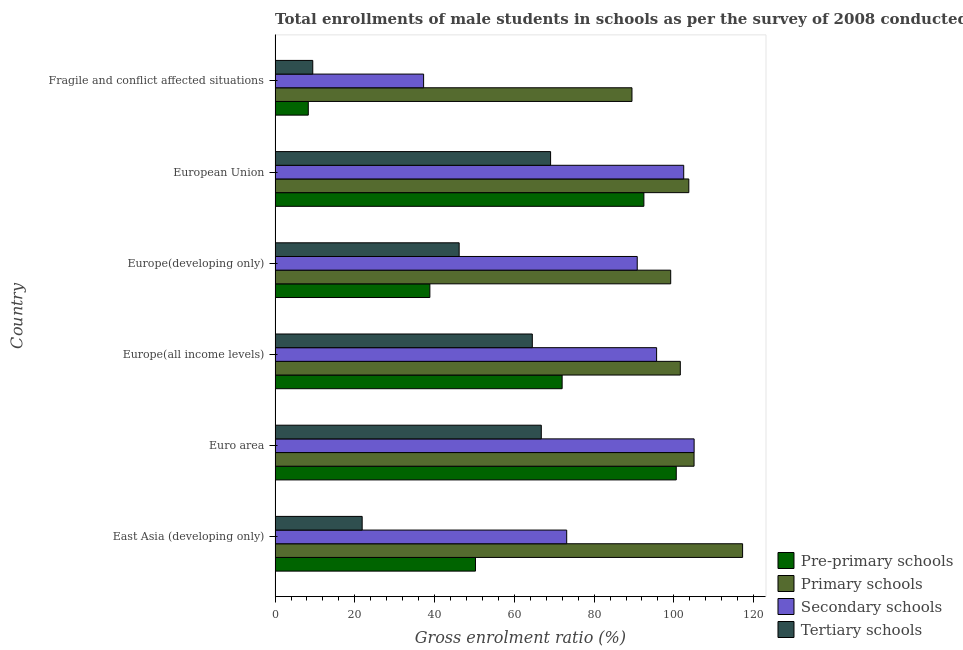How many groups of bars are there?
Make the answer very short. 6. Are the number of bars on each tick of the Y-axis equal?
Offer a very short reply. Yes. How many bars are there on the 1st tick from the top?
Offer a terse response. 4. How many bars are there on the 1st tick from the bottom?
Your answer should be very brief. 4. In how many cases, is the number of bars for a given country not equal to the number of legend labels?
Give a very brief answer. 0. What is the gross enrolment ratio(male) in primary schools in Europe(all income levels)?
Your response must be concise. 101.62. Across all countries, what is the maximum gross enrolment ratio(male) in primary schools?
Your response must be concise. 117.24. Across all countries, what is the minimum gross enrolment ratio(male) in pre-primary schools?
Provide a short and direct response. 8.33. In which country was the gross enrolment ratio(male) in pre-primary schools minimum?
Provide a succinct answer. Fragile and conflict affected situations. What is the total gross enrolment ratio(male) in primary schools in the graph?
Offer a very short reply. 616.4. What is the difference between the gross enrolment ratio(male) in tertiary schools in Euro area and that in Fragile and conflict affected situations?
Provide a succinct answer. 57.31. What is the difference between the gross enrolment ratio(male) in tertiary schools in Europe(developing only) and the gross enrolment ratio(male) in primary schools in Europe(all income levels)?
Your answer should be compact. -55.46. What is the average gross enrolment ratio(male) in primary schools per country?
Your response must be concise. 102.73. What is the difference between the gross enrolment ratio(male) in tertiary schools and gross enrolment ratio(male) in secondary schools in Europe(developing only)?
Your answer should be very brief. -44.66. What is the ratio of the gross enrolment ratio(male) in secondary schools in East Asia (developing only) to that in Europe(all income levels)?
Provide a short and direct response. 0.76. Is the difference between the gross enrolment ratio(male) in tertiary schools in Euro area and European Union greater than the difference between the gross enrolment ratio(male) in primary schools in Euro area and European Union?
Ensure brevity in your answer.  No. What is the difference between the highest and the second highest gross enrolment ratio(male) in primary schools?
Make the answer very short. 12.17. What is the difference between the highest and the lowest gross enrolment ratio(male) in primary schools?
Your response must be concise. 27.74. Is the sum of the gross enrolment ratio(male) in primary schools in Euro area and Fragile and conflict affected situations greater than the maximum gross enrolment ratio(male) in secondary schools across all countries?
Keep it short and to the point. Yes. Is it the case that in every country, the sum of the gross enrolment ratio(male) in secondary schools and gross enrolment ratio(male) in primary schools is greater than the sum of gross enrolment ratio(male) in tertiary schools and gross enrolment ratio(male) in pre-primary schools?
Offer a terse response. No. What does the 1st bar from the top in European Union represents?
Provide a succinct answer. Tertiary schools. What does the 4th bar from the bottom in Europe(all income levels) represents?
Ensure brevity in your answer.  Tertiary schools. Is it the case that in every country, the sum of the gross enrolment ratio(male) in pre-primary schools and gross enrolment ratio(male) in primary schools is greater than the gross enrolment ratio(male) in secondary schools?
Provide a succinct answer. Yes. How many countries are there in the graph?
Make the answer very short. 6. What is the difference between two consecutive major ticks on the X-axis?
Give a very brief answer. 20. Does the graph contain grids?
Ensure brevity in your answer.  No. Where does the legend appear in the graph?
Your answer should be very brief. Bottom right. How many legend labels are there?
Ensure brevity in your answer.  4. What is the title of the graph?
Provide a succinct answer. Total enrollments of male students in schools as per the survey of 2008 conducted in different countries. Does "Grants and Revenue" appear as one of the legend labels in the graph?
Your response must be concise. No. What is the Gross enrolment ratio (%) in Pre-primary schools in East Asia (developing only)?
Your response must be concise. 50.26. What is the Gross enrolment ratio (%) in Primary schools in East Asia (developing only)?
Ensure brevity in your answer.  117.24. What is the Gross enrolment ratio (%) of Secondary schools in East Asia (developing only)?
Your answer should be compact. 73.13. What is the Gross enrolment ratio (%) of Tertiary schools in East Asia (developing only)?
Your answer should be compact. 21.84. What is the Gross enrolment ratio (%) in Pre-primary schools in Euro area?
Offer a very short reply. 100.61. What is the Gross enrolment ratio (%) of Primary schools in Euro area?
Provide a short and direct response. 105.07. What is the Gross enrolment ratio (%) in Secondary schools in Euro area?
Ensure brevity in your answer.  105.08. What is the Gross enrolment ratio (%) in Tertiary schools in Euro area?
Offer a terse response. 66.76. What is the Gross enrolment ratio (%) in Pre-primary schools in Europe(all income levels)?
Offer a terse response. 71.99. What is the Gross enrolment ratio (%) in Primary schools in Europe(all income levels)?
Your response must be concise. 101.62. What is the Gross enrolment ratio (%) of Secondary schools in Europe(all income levels)?
Offer a very short reply. 95.68. What is the Gross enrolment ratio (%) in Tertiary schools in Europe(all income levels)?
Offer a very short reply. 64.51. What is the Gross enrolment ratio (%) in Pre-primary schools in Europe(developing only)?
Offer a very short reply. 38.82. What is the Gross enrolment ratio (%) of Primary schools in Europe(developing only)?
Provide a short and direct response. 99.21. What is the Gross enrolment ratio (%) of Secondary schools in Europe(developing only)?
Give a very brief answer. 90.82. What is the Gross enrolment ratio (%) of Tertiary schools in Europe(developing only)?
Your answer should be very brief. 46.16. What is the Gross enrolment ratio (%) of Pre-primary schools in European Union?
Make the answer very short. 92.49. What is the Gross enrolment ratio (%) in Primary schools in European Union?
Provide a succinct answer. 103.76. What is the Gross enrolment ratio (%) in Secondary schools in European Union?
Your answer should be very brief. 102.48. What is the Gross enrolment ratio (%) of Tertiary schools in European Union?
Offer a very short reply. 69.09. What is the Gross enrolment ratio (%) of Pre-primary schools in Fragile and conflict affected situations?
Provide a short and direct response. 8.33. What is the Gross enrolment ratio (%) in Primary schools in Fragile and conflict affected situations?
Make the answer very short. 89.5. What is the Gross enrolment ratio (%) of Secondary schools in Fragile and conflict affected situations?
Offer a terse response. 37.25. What is the Gross enrolment ratio (%) of Tertiary schools in Fragile and conflict affected situations?
Your answer should be compact. 9.45. Across all countries, what is the maximum Gross enrolment ratio (%) of Pre-primary schools?
Offer a terse response. 100.61. Across all countries, what is the maximum Gross enrolment ratio (%) in Primary schools?
Offer a very short reply. 117.24. Across all countries, what is the maximum Gross enrolment ratio (%) of Secondary schools?
Offer a very short reply. 105.08. Across all countries, what is the maximum Gross enrolment ratio (%) in Tertiary schools?
Ensure brevity in your answer.  69.09. Across all countries, what is the minimum Gross enrolment ratio (%) in Pre-primary schools?
Your response must be concise. 8.33. Across all countries, what is the minimum Gross enrolment ratio (%) of Primary schools?
Ensure brevity in your answer.  89.5. Across all countries, what is the minimum Gross enrolment ratio (%) in Secondary schools?
Your answer should be compact. 37.25. Across all countries, what is the minimum Gross enrolment ratio (%) of Tertiary schools?
Give a very brief answer. 9.45. What is the total Gross enrolment ratio (%) in Pre-primary schools in the graph?
Provide a short and direct response. 362.48. What is the total Gross enrolment ratio (%) in Primary schools in the graph?
Offer a terse response. 616.4. What is the total Gross enrolment ratio (%) in Secondary schools in the graph?
Keep it short and to the point. 504.44. What is the total Gross enrolment ratio (%) in Tertiary schools in the graph?
Offer a very short reply. 277.82. What is the difference between the Gross enrolment ratio (%) of Pre-primary schools in East Asia (developing only) and that in Euro area?
Provide a short and direct response. -50.35. What is the difference between the Gross enrolment ratio (%) of Primary schools in East Asia (developing only) and that in Euro area?
Make the answer very short. 12.17. What is the difference between the Gross enrolment ratio (%) in Secondary schools in East Asia (developing only) and that in Euro area?
Offer a terse response. -31.95. What is the difference between the Gross enrolment ratio (%) in Tertiary schools in East Asia (developing only) and that in Euro area?
Provide a short and direct response. -44.92. What is the difference between the Gross enrolment ratio (%) of Pre-primary schools in East Asia (developing only) and that in Europe(all income levels)?
Provide a succinct answer. -21.73. What is the difference between the Gross enrolment ratio (%) in Primary schools in East Asia (developing only) and that in Europe(all income levels)?
Offer a very short reply. 15.62. What is the difference between the Gross enrolment ratio (%) in Secondary schools in East Asia (developing only) and that in Europe(all income levels)?
Your answer should be compact. -22.55. What is the difference between the Gross enrolment ratio (%) in Tertiary schools in East Asia (developing only) and that in Europe(all income levels)?
Your answer should be compact. -42.67. What is the difference between the Gross enrolment ratio (%) in Pre-primary schools in East Asia (developing only) and that in Europe(developing only)?
Provide a succinct answer. 11.44. What is the difference between the Gross enrolment ratio (%) in Primary schools in East Asia (developing only) and that in Europe(developing only)?
Your answer should be very brief. 18.03. What is the difference between the Gross enrolment ratio (%) of Secondary schools in East Asia (developing only) and that in Europe(developing only)?
Your answer should be compact. -17.69. What is the difference between the Gross enrolment ratio (%) of Tertiary schools in East Asia (developing only) and that in Europe(developing only)?
Offer a terse response. -24.32. What is the difference between the Gross enrolment ratio (%) in Pre-primary schools in East Asia (developing only) and that in European Union?
Offer a terse response. -42.23. What is the difference between the Gross enrolment ratio (%) in Primary schools in East Asia (developing only) and that in European Union?
Keep it short and to the point. 13.49. What is the difference between the Gross enrolment ratio (%) of Secondary schools in East Asia (developing only) and that in European Union?
Your response must be concise. -29.35. What is the difference between the Gross enrolment ratio (%) in Tertiary schools in East Asia (developing only) and that in European Union?
Offer a terse response. -47.25. What is the difference between the Gross enrolment ratio (%) of Pre-primary schools in East Asia (developing only) and that in Fragile and conflict affected situations?
Provide a succinct answer. 41.93. What is the difference between the Gross enrolment ratio (%) in Primary schools in East Asia (developing only) and that in Fragile and conflict affected situations?
Keep it short and to the point. 27.74. What is the difference between the Gross enrolment ratio (%) of Secondary schools in East Asia (developing only) and that in Fragile and conflict affected situations?
Make the answer very short. 35.88. What is the difference between the Gross enrolment ratio (%) of Tertiary schools in East Asia (developing only) and that in Fragile and conflict affected situations?
Keep it short and to the point. 12.39. What is the difference between the Gross enrolment ratio (%) of Pre-primary schools in Euro area and that in Europe(all income levels)?
Offer a very short reply. 28.62. What is the difference between the Gross enrolment ratio (%) in Primary schools in Euro area and that in Europe(all income levels)?
Your response must be concise. 3.45. What is the difference between the Gross enrolment ratio (%) in Secondary schools in Euro area and that in Europe(all income levels)?
Keep it short and to the point. 9.41. What is the difference between the Gross enrolment ratio (%) in Tertiary schools in Euro area and that in Europe(all income levels)?
Your response must be concise. 2.25. What is the difference between the Gross enrolment ratio (%) in Pre-primary schools in Euro area and that in Europe(developing only)?
Ensure brevity in your answer.  61.79. What is the difference between the Gross enrolment ratio (%) in Primary schools in Euro area and that in Europe(developing only)?
Offer a terse response. 5.86. What is the difference between the Gross enrolment ratio (%) of Secondary schools in Euro area and that in Europe(developing only)?
Make the answer very short. 14.26. What is the difference between the Gross enrolment ratio (%) of Tertiary schools in Euro area and that in Europe(developing only)?
Give a very brief answer. 20.6. What is the difference between the Gross enrolment ratio (%) in Pre-primary schools in Euro area and that in European Union?
Keep it short and to the point. 8.12. What is the difference between the Gross enrolment ratio (%) of Primary schools in Euro area and that in European Union?
Offer a very short reply. 1.31. What is the difference between the Gross enrolment ratio (%) of Secondary schools in Euro area and that in European Union?
Provide a succinct answer. 2.61. What is the difference between the Gross enrolment ratio (%) of Tertiary schools in Euro area and that in European Union?
Provide a succinct answer. -2.33. What is the difference between the Gross enrolment ratio (%) of Pre-primary schools in Euro area and that in Fragile and conflict affected situations?
Keep it short and to the point. 92.28. What is the difference between the Gross enrolment ratio (%) of Primary schools in Euro area and that in Fragile and conflict affected situations?
Keep it short and to the point. 15.57. What is the difference between the Gross enrolment ratio (%) of Secondary schools in Euro area and that in Fragile and conflict affected situations?
Make the answer very short. 67.84. What is the difference between the Gross enrolment ratio (%) of Tertiary schools in Euro area and that in Fragile and conflict affected situations?
Provide a succinct answer. 57.31. What is the difference between the Gross enrolment ratio (%) in Pre-primary schools in Europe(all income levels) and that in Europe(developing only)?
Your response must be concise. 33.17. What is the difference between the Gross enrolment ratio (%) of Primary schools in Europe(all income levels) and that in Europe(developing only)?
Your answer should be compact. 2.41. What is the difference between the Gross enrolment ratio (%) in Secondary schools in Europe(all income levels) and that in Europe(developing only)?
Keep it short and to the point. 4.86. What is the difference between the Gross enrolment ratio (%) of Tertiary schools in Europe(all income levels) and that in Europe(developing only)?
Your answer should be compact. 18.35. What is the difference between the Gross enrolment ratio (%) in Pre-primary schools in Europe(all income levels) and that in European Union?
Give a very brief answer. -20.5. What is the difference between the Gross enrolment ratio (%) in Primary schools in Europe(all income levels) and that in European Union?
Make the answer very short. -2.13. What is the difference between the Gross enrolment ratio (%) in Secondary schools in Europe(all income levels) and that in European Union?
Offer a terse response. -6.8. What is the difference between the Gross enrolment ratio (%) in Tertiary schools in Europe(all income levels) and that in European Union?
Give a very brief answer. -4.58. What is the difference between the Gross enrolment ratio (%) in Pre-primary schools in Europe(all income levels) and that in Fragile and conflict affected situations?
Ensure brevity in your answer.  63.66. What is the difference between the Gross enrolment ratio (%) in Primary schools in Europe(all income levels) and that in Fragile and conflict affected situations?
Ensure brevity in your answer.  12.12. What is the difference between the Gross enrolment ratio (%) of Secondary schools in Europe(all income levels) and that in Fragile and conflict affected situations?
Your response must be concise. 58.43. What is the difference between the Gross enrolment ratio (%) in Tertiary schools in Europe(all income levels) and that in Fragile and conflict affected situations?
Provide a short and direct response. 55.06. What is the difference between the Gross enrolment ratio (%) in Pre-primary schools in Europe(developing only) and that in European Union?
Give a very brief answer. -53.67. What is the difference between the Gross enrolment ratio (%) of Primary schools in Europe(developing only) and that in European Union?
Your answer should be very brief. -4.54. What is the difference between the Gross enrolment ratio (%) of Secondary schools in Europe(developing only) and that in European Union?
Your response must be concise. -11.66. What is the difference between the Gross enrolment ratio (%) in Tertiary schools in Europe(developing only) and that in European Union?
Give a very brief answer. -22.93. What is the difference between the Gross enrolment ratio (%) of Pre-primary schools in Europe(developing only) and that in Fragile and conflict affected situations?
Your answer should be compact. 30.49. What is the difference between the Gross enrolment ratio (%) of Primary schools in Europe(developing only) and that in Fragile and conflict affected situations?
Your answer should be very brief. 9.71. What is the difference between the Gross enrolment ratio (%) in Secondary schools in Europe(developing only) and that in Fragile and conflict affected situations?
Make the answer very short. 53.57. What is the difference between the Gross enrolment ratio (%) in Tertiary schools in Europe(developing only) and that in Fragile and conflict affected situations?
Provide a succinct answer. 36.71. What is the difference between the Gross enrolment ratio (%) in Pre-primary schools in European Union and that in Fragile and conflict affected situations?
Your answer should be compact. 84.16. What is the difference between the Gross enrolment ratio (%) of Primary schools in European Union and that in Fragile and conflict affected situations?
Provide a short and direct response. 14.26. What is the difference between the Gross enrolment ratio (%) in Secondary schools in European Union and that in Fragile and conflict affected situations?
Ensure brevity in your answer.  65.23. What is the difference between the Gross enrolment ratio (%) of Tertiary schools in European Union and that in Fragile and conflict affected situations?
Ensure brevity in your answer.  59.64. What is the difference between the Gross enrolment ratio (%) of Pre-primary schools in East Asia (developing only) and the Gross enrolment ratio (%) of Primary schools in Euro area?
Your answer should be compact. -54.81. What is the difference between the Gross enrolment ratio (%) in Pre-primary schools in East Asia (developing only) and the Gross enrolment ratio (%) in Secondary schools in Euro area?
Your response must be concise. -54.83. What is the difference between the Gross enrolment ratio (%) of Pre-primary schools in East Asia (developing only) and the Gross enrolment ratio (%) of Tertiary schools in Euro area?
Ensure brevity in your answer.  -16.51. What is the difference between the Gross enrolment ratio (%) in Primary schools in East Asia (developing only) and the Gross enrolment ratio (%) in Secondary schools in Euro area?
Offer a very short reply. 12.16. What is the difference between the Gross enrolment ratio (%) in Primary schools in East Asia (developing only) and the Gross enrolment ratio (%) in Tertiary schools in Euro area?
Your response must be concise. 50.48. What is the difference between the Gross enrolment ratio (%) of Secondary schools in East Asia (developing only) and the Gross enrolment ratio (%) of Tertiary schools in Euro area?
Your answer should be very brief. 6.37. What is the difference between the Gross enrolment ratio (%) in Pre-primary schools in East Asia (developing only) and the Gross enrolment ratio (%) in Primary schools in Europe(all income levels)?
Your answer should be compact. -51.37. What is the difference between the Gross enrolment ratio (%) in Pre-primary schools in East Asia (developing only) and the Gross enrolment ratio (%) in Secondary schools in Europe(all income levels)?
Provide a succinct answer. -45.42. What is the difference between the Gross enrolment ratio (%) of Pre-primary schools in East Asia (developing only) and the Gross enrolment ratio (%) of Tertiary schools in Europe(all income levels)?
Give a very brief answer. -14.25. What is the difference between the Gross enrolment ratio (%) of Primary schools in East Asia (developing only) and the Gross enrolment ratio (%) of Secondary schools in Europe(all income levels)?
Offer a terse response. 21.57. What is the difference between the Gross enrolment ratio (%) in Primary schools in East Asia (developing only) and the Gross enrolment ratio (%) in Tertiary schools in Europe(all income levels)?
Provide a succinct answer. 52.73. What is the difference between the Gross enrolment ratio (%) in Secondary schools in East Asia (developing only) and the Gross enrolment ratio (%) in Tertiary schools in Europe(all income levels)?
Your response must be concise. 8.62. What is the difference between the Gross enrolment ratio (%) in Pre-primary schools in East Asia (developing only) and the Gross enrolment ratio (%) in Primary schools in Europe(developing only)?
Give a very brief answer. -48.96. What is the difference between the Gross enrolment ratio (%) of Pre-primary schools in East Asia (developing only) and the Gross enrolment ratio (%) of Secondary schools in Europe(developing only)?
Provide a succinct answer. -40.57. What is the difference between the Gross enrolment ratio (%) in Pre-primary schools in East Asia (developing only) and the Gross enrolment ratio (%) in Tertiary schools in Europe(developing only)?
Your answer should be very brief. 4.09. What is the difference between the Gross enrolment ratio (%) of Primary schools in East Asia (developing only) and the Gross enrolment ratio (%) of Secondary schools in Europe(developing only)?
Provide a succinct answer. 26.42. What is the difference between the Gross enrolment ratio (%) of Primary schools in East Asia (developing only) and the Gross enrolment ratio (%) of Tertiary schools in Europe(developing only)?
Ensure brevity in your answer.  71.08. What is the difference between the Gross enrolment ratio (%) of Secondary schools in East Asia (developing only) and the Gross enrolment ratio (%) of Tertiary schools in Europe(developing only)?
Provide a short and direct response. 26.97. What is the difference between the Gross enrolment ratio (%) in Pre-primary schools in East Asia (developing only) and the Gross enrolment ratio (%) in Primary schools in European Union?
Make the answer very short. -53.5. What is the difference between the Gross enrolment ratio (%) of Pre-primary schools in East Asia (developing only) and the Gross enrolment ratio (%) of Secondary schools in European Union?
Your answer should be very brief. -52.22. What is the difference between the Gross enrolment ratio (%) in Pre-primary schools in East Asia (developing only) and the Gross enrolment ratio (%) in Tertiary schools in European Union?
Your answer should be very brief. -18.84. What is the difference between the Gross enrolment ratio (%) in Primary schools in East Asia (developing only) and the Gross enrolment ratio (%) in Secondary schools in European Union?
Ensure brevity in your answer.  14.76. What is the difference between the Gross enrolment ratio (%) in Primary schools in East Asia (developing only) and the Gross enrolment ratio (%) in Tertiary schools in European Union?
Provide a succinct answer. 48.15. What is the difference between the Gross enrolment ratio (%) in Secondary schools in East Asia (developing only) and the Gross enrolment ratio (%) in Tertiary schools in European Union?
Your answer should be compact. 4.04. What is the difference between the Gross enrolment ratio (%) in Pre-primary schools in East Asia (developing only) and the Gross enrolment ratio (%) in Primary schools in Fragile and conflict affected situations?
Provide a succinct answer. -39.24. What is the difference between the Gross enrolment ratio (%) in Pre-primary schools in East Asia (developing only) and the Gross enrolment ratio (%) in Secondary schools in Fragile and conflict affected situations?
Offer a terse response. 13.01. What is the difference between the Gross enrolment ratio (%) in Pre-primary schools in East Asia (developing only) and the Gross enrolment ratio (%) in Tertiary schools in Fragile and conflict affected situations?
Your answer should be very brief. 40.8. What is the difference between the Gross enrolment ratio (%) of Primary schools in East Asia (developing only) and the Gross enrolment ratio (%) of Secondary schools in Fragile and conflict affected situations?
Your answer should be very brief. 79.99. What is the difference between the Gross enrolment ratio (%) of Primary schools in East Asia (developing only) and the Gross enrolment ratio (%) of Tertiary schools in Fragile and conflict affected situations?
Provide a succinct answer. 107.79. What is the difference between the Gross enrolment ratio (%) of Secondary schools in East Asia (developing only) and the Gross enrolment ratio (%) of Tertiary schools in Fragile and conflict affected situations?
Give a very brief answer. 63.68. What is the difference between the Gross enrolment ratio (%) in Pre-primary schools in Euro area and the Gross enrolment ratio (%) in Primary schools in Europe(all income levels)?
Provide a succinct answer. -1.01. What is the difference between the Gross enrolment ratio (%) in Pre-primary schools in Euro area and the Gross enrolment ratio (%) in Secondary schools in Europe(all income levels)?
Give a very brief answer. 4.93. What is the difference between the Gross enrolment ratio (%) in Pre-primary schools in Euro area and the Gross enrolment ratio (%) in Tertiary schools in Europe(all income levels)?
Your answer should be compact. 36.1. What is the difference between the Gross enrolment ratio (%) of Primary schools in Euro area and the Gross enrolment ratio (%) of Secondary schools in Europe(all income levels)?
Offer a very short reply. 9.39. What is the difference between the Gross enrolment ratio (%) of Primary schools in Euro area and the Gross enrolment ratio (%) of Tertiary schools in Europe(all income levels)?
Make the answer very short. 40.56. What is the difference between the Gross enrolment ratio (%) in Secondary schools in Euro area and the Gross enrolment ratio (%) in Tertiary schools in Europe(all income levels)?
Keep it short and to the point. 40.58. What is the difference between the Gross enrolment ratio (%) of Pre-primary schools in Euro area and the Gross enrolment ratio (%) of Primary schools in Europe(developing only)?
Keep it short and to the point. 1.4. What is the difference between the Gross enrolment ratio (%) in Pre-primary schools in Euro area and the Gross enrolment ratio (%) in Secondary schools in Europe(developing only)?
Your answer should be very brief. 9.79. What is the difference between the Gross enrolment ratio (%) in Pre-primary schools in Euro area and the Gross enrolment ratio (%) in Tertiary schools in Europe(developing only)?
Your answer should be compact. 54.45. What is the difference between the Gross enrolment ratio (%) in Primary schools in Euro area and the Gross enrolment ratio (%) in Secondary schools in Europe(developing only)?
Make the answer very short. 14.25. What is the difference between the Gross enrolment ratio (%) of Primary schools in Euro area and the Gross enrolment ratio (%) of Tertiary schools in Europe(developing only)?
Provide a succinct answer. 58.91. What is the difference between the Gross enrolment ratio (%) of Secondary schools in Euro area and the Gross enrolment ratio (%) of Tertiary schools in Europe(developing only)?
Provide a short and direct response. 58.92. What is the difference between the Gross enrolment ratio (%) in Pre-primary schools in Euro area and the Gross enrolment ratio (%) in Primary schools in European Union?
Your response must be concise. -3.15. What is the difference between the Gross enrolment ratio (%) of Pre-primary schools in Euro area and the Gross enrolment ratio (%) of Secondary schools in European Union?
Your answer should be compact. -1.87. What is the difference between the Gross enrolment ratio (%) in Pre-primary schools in Euro area and the Gross enrolment ratio (%) in Tertiary schools in European Union?
Make the answer very short. 31.51. What is the difference between the Gross enrolment ratio (%) of Primary schools in Euro area and the Gross enrolment ratio (%) of Secondary schools in European Union?
Keep it short and to the point. 2.59. What is the difference between the Gross enrolment ratio (%) in Primary schools in Euro area and the Gross enrolment ratio (%) in Tertiary schools in European Union?
Your answer should be compact. 35.97. What is the difference between the Gross enrolment ratio (%) in Secondary schools in Euro area and the Gross enrolment ratio (%) in Tertiary schools in European Union?
Make the answer very short. 35.99. What is the difference between the Gross enrolment ratio (%) in Pre-primary schools in Euro area and the Gross enrolment ratio (%) in Primary schools in Fragile and conflict affected situations?
Ensure brevity in your answer.  11.11. What is the difference between the Gross enrolment ratio (%) of Pre-primary schools in Euro area and the Gross enrolment ratio (%) of Secondary schools in Fragile and conflict affected situations?
Your answer should be compact. 63.36. What is the difference between the Gross enrolment ratio (%) of Pre-primary schools in Euro area and the Gross enrolment ratio (%) of Tertiary schools in Fragile and conflict affected situations?
Offer a very short reply. 91.16. What is the difference between the Gross enrolment ratio (%) of Primary schools in Euro area and the Gross enrolment ratio (%) of Secondary schools in Fragile and conflict affected situations?
Offer a very short reply. 67.82. What is the difference between the Gross enrolment ratio (%) of Primary schools in Euro area and the Gross enrolment ratio (%) of Tertiary schools in Fragile and conflict affected situations?
Give a very brief answer. 95.62. What is the difference between the Gross enrolment ratio (%) in Secondary schools in Euro area and the Gross enrolment ratio (%) in Tertiary schools in Fragile and conflict affected situations?
Make the answer very short. 95.63. What is the difference between the Gross enrolment ratio (%) of Pre-primary schools in Europe(all income levels) and the Gross enrolment ratio (%) of Primary schools in Europe(developing only)?
Your response must be concise. -27.23. What is the difference between the Gross enrolment ratio (%) of Pre-primary schools in Europe(all income levels) and the Gross enrolment ratio (%) of Secondary schools in Europe(developing only)?
Offer a very short reply. -18.84. What is the difference between the Gross enrolment ratio (%) in Pre-primary schools in Europe(all income levels) and the Gross enrolment ratio (%) in Tertiary schools in Europe(developing only)?
Your response must be concise. 25.82. What is the difference between the Gross enrolment ratio (%) of Primary schools in Europe(all income levels) and the Gross enrolment ratio (%) of Secondary schools in Europe(developing only)?
Your answer should be compact. 10.8. What is the difference between the Gross enrolment ratio (%) of Primary schools in Europe(all income levels) and the Gross enrolment ratio (%) of Tertiary schools in Europe(developing only)?
Your response must be concise. 55.46. What is the difference between the Gross enrolment ratio (%) in Secondary schools in Europe(all income levels) and the Gross enrolment ratio (%) in Tertiary schools in Europe(developing only)?
Offer a very short reply. 49.52. What is the difference between the Gross enrolment ratio (%) of Pre-primary schools in Europe(all income levels) and the Gross enrolment ratio (%) of Primary schools in European Union?
Make the answer very short. -31.77. What is the difference between the Gross enrolment ratio (%) in Pre-primary schools in Europe(all income levels) and the Gross enrolment ratio (%) in Secondary schools in European Union?
Provide a succinct answer. -30.49. What is the difference between the Gross enrolment ratio (%) in Pre-primary schools in Europe(all income levels) and the Gross enrolment ratio (%) in Tertiary schools in European Union?
Make the answer very short. 2.89. What is the difference between the Gross enrolment ratio (%) in Primary schools in Europe(all income levels) and the Gross enrolment ratio (%) in Secondary schools in European Union?
Your answer should be compact. -0.86. What is the difference between the Gross enrolment ratio (%) of Primary schools in Europe(all income levels) and the Gross enrolment ratio (%) of Tertiary schools in European Union?
Your answer should be compact. 32.53. What is the difference between the Gross enrolment ratio (%) of Secondary schools in Europe(all income levels) and the Gross enrolment ratio (%) of Tertiary schools in European Union?
Offer a very short reply. 26.58. What is the difference between the Gross enrolment ratio (%) of Pre-primary schools in Europe(all income levels) and the Gross enrolment ratio (%) of Primary schools in Fragile and conflict affected situations?
Make the answer very short. -17.51. What is the difference between the Gross enrolment ratio (%) in Pre-primary schools in Europe(all income levels) and the Gross enrolment ratio (%) in Secondary schools in Fragile and conflict affected situations?
Give a very brief answer. 34.74. What is the difference between the Gross enrolment ratio (%) in Pre-primary schools in Europe(all income levels) and the Gross enrolment ratio (%) in Tertiary schools in Fragile and conflict affected situations?
Give a very brief answer. 62.53. What is the difference between the Gross enrolment ratio (%) in Primary schools in Europe(all income levels) and the Gross enrolment ratio (%) in Secondary schools in Fragile and conflict affected situations?
Make the answer very short. 64.37. What is the difference between the Gross enrolment ratio (%) in Primary schools in Europe(all income levels) and the Gross enrolment ratio (%) in Tertiary schools in Fragile and conflict affected situations?
Offer a very short reply. 92.17. What is the difference between the Gross enrolment ratio (%) of Secondary schools in Europe(all income levels) and the Gross enrolment ratio (%) of Tertiary schools in Fragile and conflict affected situations?
Your answer should be compact. 86.23. What is the difference between the Gross enrolment ratio (%) in Pre-primary schools in Europe(developing only) and the Gross enrolment ratio (%) in Primary schools in European Union?
Your answer should be very brief. -64.94. What is the difference between the Gross enrolment ratio (%) in Pre-primary schools in Europe(developing only) and the Gross enrolment ratio (%) in Secondary schools in European Union?
Provide a short and direct response. -63.66. What is the difference between the Gross enrolment ratio (%) in Pre-primary schools in Europe(developing only) and the Gross enrolment ratio (%) in Tertiary schools in European Union?
Your response must be concise. -30.27. What is the difference between the Gross enrolment ratio (%) of Primary schools in Europe(developing only) and the Gross enrolment ratio (%) of Secondary schools in European Union?
Make the answer very short. -3.27. What is the difference between the Gross enrolment ratio (%) of Primary schools in Europe(developing only) and the Gross enrolment ratio (%) of Tertiary schools in European Union?
Give a very brief answer. 30.12. What is the difference between the Gross enrolment ratio (%) of Secondary schools in Europe(developing only) and the Gross enrolment ratio (%) of Tertiary schools in European Union?
Offer a very short reply. 21.73. What is the difference between the Gross enrolment ratio (%) of Pre-primary schools in Europe(developing only) and the Gross enrolment ratio (%) of Primary schools in Fragile and conflict affected situations?
Provide a short and direct response. -50.68. What is the difference between the Gross enrolment ratio (%) of Pre-primary schools in Europe(developing only) and the Gross enrolment ratio (%) of Secondary schools in Fragile and conflict affected situations?
Your answer should be compact. 1.57. What is the difference between the Gross enrolment ratio (%) of Pre-primary schools in Europe(developing only) and the Gross enrolment ratio (%) of Tertiary schools in Fragile and conflict affected situations?
Offer a terse response. 29.37. What is the difference between the Gross enrolment ratio (%) in Primary schools in Europe(developing only) and the Gross enrolment ratio (%) in Secondary schools in Fragile and conflict affected situations?
Ensure brevity in your answer.  61.96. What is the difference between the Gross enrolment ratio (%) of Primary schools in Europe(developing only) and the Gross enrolment ratio (%) of Tertiary schools in Fragile and conflict affected situations?
Your response must be concise. 89.76. What is the difference between the Gross enrolment ratio (%) in Secondary schools in Europe(developing only) and the Gross enrolment ratio (%) in Tertiary schools in Fragile and conflict affected situations?
Your answer should be compact. 81.37. What is the difference between the Gross enrolment ratio (%) of Pre-primary schools in European Union and the Gross enrolment ratio (%) of Primary schools in Fragile and conflict affected situations?
Offer a terse response. 2.99. What is the difference between the Gross enrolment ratio (%) in Pre-primary schools in European Union and the Gross enrolment ratio (%) in Secondary schools in Fragile and conflict affected situations?
Provide a succinct answer. 55.24. What is the difference between the Gross enrolment ratio (%) of Pre-primary schools in European Union and the Gross enrolment ratio (%) of Tertiary schools in Fragile and conflict affected situations?
Your answer should be very brief. 83.04. What is the difference between the Gross enrolment ratio (%) of Primary schools in European Union and the Gross enrolment ratio (%) of Secondary schools in Fragile and conflict affected situations?
Your response must be concise. 66.51. What is the difference between the Gross enrolment ratio (%) in Primary schools in European Union and the Gross enrolment ratio (%) in Tertiary schools in Fragile and conflict affected situations?
Ensure brevity in your answer.  94.3. What is the difference between the Gross enrolment ratio (%) of Secondary schools in European Union and the Gross enrolment ratio (%) of Tertiary schools in Fragile and conflict affected situations?
Offer a very short reply. 93.03. What is the average Gross enrolment ratio (%) in Pre-primary schools per country?
Keep it short and to the point. 60.41. What is the average Gross enrolment ratio (%) in Primary schools per country?
Your response must be concise. 102.73. What is the average Gross enrolment ratio (%) in Secondary schools per country?
Your answer should be very brief. 84.07. What is the average Gross enrolment ratio (%) in Tertiary schools per country?
Provide a succinct answer. 46.3. What is the difference between the Gross enrolment ratio (%) in Pre-primary schools and Gross enrolment ratio (%) in Primary schools in East Asia (developing only)?
Provide a succinct answer. -66.99. What is the difference between the Gross enrolment ratio (%) in Pre-primary schools and Gross enrolment ratio (%) in Secondary schools in East Asia (developing only)?
Offer a very short reply. -22.87. What is the difference between the Gross enrolment ratio (%) of Pre-primary schools and Gross enrolment ratio (%) of Tertiary schools in East Asia (developing only)?
Your response must be concise. 28.42. What is the difference between the Gross enrolment ratio (%) in Primary schools and Gross enrolment ratio (%) in Secondary schools in East Asia (developing only)?
Offer a terse response. 44.11. What is the difference between the Gross enrolment ratio (%) of Primary schools and Gross enrolment ratio (%) of Tertiary schools in East Asia (developing only)?
Offer a very short reply. 95.4. What is the difference between the Gross enrolment ratio (%) in Secondary schools and Gross enrolment ratio (%) in Tertiary schools in East Asia (developing only)?
Ensure brevity in your answer.  51.29. What is the difference between the Gross enrolment ratio (%) of Pre-primary schools and Gross enrolment ratio (%) of Primary schools in Euro area?
Your answer should be very brief. -4.46. What is the difference between the Gross enrolment ratio (%) of Pre-primary schools and Gross enrolment ratio (%) of Secondary schools in Euro area?
Keep it short and to the point. -4.48. What is the difference between the Gross enrolment ratio (%) in Pre-primary schools and Gross enrolment ratio (%) in Tertiary schools in Euro area?
Your answer should be very brief. 33.85. What is the difference between the Gross enrolment ratio (%) of Primary schools and Gross enrolment ratio (%) of Secondary schools in Euro area?
Provide a short and direct response. -0.02. What is the difference between the Gross enrolment ratio (%) in Primary schools and Gross enrolment ratio (%) in Tertiary schools in Euro area?
Offer a terse response. 38.31. What is the difference between the Gross enrolment ratio (%) in Secondary schools and Gross enrolment ratio (%) in Tertiary schools in Euro area?
Make the answer very short. 38.32. What is the difference between the Gross enrolment ratio (%) in Pre-primary schools and Gross enrolment ratio (%) in Primary schools in Europe(all income levels)?
Provide a short and direct response. -29.64. What is the difference between the Gross enrolment ratio (%) in Pre-primary schools and Gross enrolment ratio (%) in Secondary schools in Europe(all income levels)?
Ensure brevity in your answer.  -23.69. What is the difference between the Gross enrolment ratio (%) of Pre-primary schools and Gross enrolment ratio (%) of Tertiary schools in Europe(all income levels)?
Offer a terse response. 7.48. What is the difference between the Gross enrolment ratio (%) in Primary schools and Gross enrolment ratio (%) in Secondary schools in Europe(all income levels)?
Make the answer very short. 5.94. What is the difference between the Gross enrolment ratio (%) of Primary schools and Gross enrolment ratio (%) of Tertiary schools in Europe(all income levels)?
Provide a short and direct response. 37.11. What is the difference between the Gross enrolment ratio (%) of Secondary schools and Gross enrolment ratio (%) of Tertiary schools in Europe(all income levels)?
Ensure brevity in your answer.  31.17. What is the difference between the Gross enrolment ratio (%) of Pre-primary schools and Gross enrolment ratio (%) of Primary schools in Europe(developing only)?
Keep it short and to the point. -60.39. What is the difference between the Gross enrolment ratio (%) in Pre-primary schools and Gross enrolment ratio (%) in Secondary schools in Europe(developing only)?
Your response must be concise. -52. What is the difference between the Gross enrolment ratio (%) in Pre-primary schools and Gross enrolment ratio (%) in Tertiary schools in Europe(developing only)?
Provide a short and direct response. -7.34. What is the difference between the Gross enrolment ratio (%) of Primary schools and Gross enrolment ratio (%) of Secondary schools in Europe(developing only)?
Give a very brief answer. 8.39. What is the difference between the Gross enrolment ratio (%) of Primary schools and Gross enrolment ratio (%) of Tertiary schools in Europe(developing only)?
Give a very brief answer. 53.05. What is the difference between the Gross enrolment ratio (%) in Secondary schools and Gross enrolment ratio (%) in Tertiary schools in Europe(developing only)?
Offer a very short reply. 44.66. What is the difference between the Gross enrolment ratio (%) in Pre-primary schools and Gross enrolment ratio (%) in Primary schools in European Union?
Make the answer very short. -11.27. What is the difference between the Gross enrolment ratio (%) of Pre-primary schools and Gross enrolment ratio (%) of Secondary schools in European Union?
Offer a terse response. -9.99. What is the difference between the Gross enrolment ratio (%) of Pre-primary schools and Gross enrolment ratio (%) of Tertiary schools in European Union?
Ensure brevity in your answer.  23.39. What is the difference between the Gross enrolment ratio (%) in Primary schools and Gross enrolment ratio (%) in Secondary schools in European Union?
Offer a terse response. 1.28. What is the difference between the Gross enrolment ratio (%) in Primary schools and Gross enrolment ratio (%) in Tertiary schools in European Union?
Your response must be concise. 34.66. What is the difference between the Gross enrolment ratio (%) of Secondary schools and Gross enrolment ratio (%) of Tertiary schools in European Union?
Provide a succinct answer. 33.38. What is the difference between the Gross enrolment ratio (%) of Pre-primary schools and Gross enrolment ratio (%) of Primary schools in Fragile and conflict affected situations?
Provide a succinct answer. -81.17. What is the difference between the Gross enrolment ratio (%) of Pre-primary schools and Gross enrolment ratio (%) of Secondary schools in Fragile and conflict affected situations?
Provide a short and direct response. -28.92. What is the difference between the Gross enrolment ratio (%) in Pre-primary schools and Gross enrolment ratio (%) in Tertiary schools in Fragile and conflict affected situations?
Offer a terse response. -1.12. What is the difference between the Gross enrolment ratio (%) of Primary schools and Gross enrolment ratio (%) of Secondary schools in Fragile and conflict affected situations?
Offer a terse response. 52.25. What is the difference between the Gross enrolment ratio (%) of Primary schools and Gross enrolment ratio (%) of Tertiary schools in Fragile and conflict affected situations?
Ensure brevity in your answer.  80.05. What is the difference between the Gross enrolment ratio (%) of Secondary schools and Gross enrolment ratio (%) of Tertiary schools in Fragile and conflict affected situations?
Your answer should be compact. 27.8. What is the ratio of the Gross enrolment ratio (%) of Pre-primary schools in East Asia (developing only) to that in Euro area?
Provide a succinct answer. 0.5. What is the ratio of the Gross enrolment ratio (%) in Primary schools in East Asia (developing only) to that in Euro area?
Your answer should be very brief. 1.12. What is the ratio of the Gross enrolment ratio (%) of Secondary schools in East Asia (developing only) to that in Euro area?
Provide a short and direct response. 0.7. What is the ratio of the Gross enrolment ratio (%) of Tertiary schools in East Asia (developing only) to that in Euro area?
Your answer should be compact. 0.33. What is the ratio of the Gross enrolment ratio (%) of Pre-primary schools in East Asia (developing only) to that in Europe(all income levels)?
Offer a terse response. 0.7. What is the ratio of the Gross enrolment ratio (%) in Primary schools in East Asia (developing only) to that in Europe(all income levels)?
Offer a terse response. 1.15. What is the ratio of the Gross enrolment ratio (%) of Secondary schools in East Asia (developing only) to that in Europe(all income levels)?
Offer a terse response. 0.76. What is the ratio of the Gross enrolment ratio (%) in Tertiary schools in East Asia (developing only) to that in Europe(all income levels)?
Offer a terse response. 0.34. What is the ratio of the Gross enrolment ratio (%) in Pre-primary schools in East Asia (developing only) to that in Europe(developing only)?
Your answer should be compact. 1.29. What is the ratio of the Gross enrolment ratio (%) in Primary schools in East Asia (developing only) to that in Europe(developing only)?
Provide a short and direct response. 1.18. What is the ratio of the Gross enrolment ratio (%) in Secondary schools in East Asia (developing only) to that in Europe(developing only)?
Your response must be concise. 0.81. What is the ratio of the Gross enrolment ratio (%) in Tertiary schools in East Asia (developing only) to that in Europe(developing only)?
Provide a short and direct response. 0.47. What is the ratio of the Gross enrolment ratio (%) of Pre-primary schools in East Asia (developing only) to that in European Union?
Ensure brevity in your answer.  0.54. What is the ratio of the Gross enrolment ratio (%) of Primary schools in East Asia (developing only) to that in European Union?
Your response must be concise. 1.13. What is the ratio of the Gross enrolment ratio (%) in Secondary schools in East Asia (developing only) to that in European Union?
Provide a short and direct response. 0.71. What is the ratio of the Gross enrolment ratio (%) of Tertiary schools in East Asia (developing only) to that in European Union?
Your answer should be compact. 0.32. What is the ratio of the Gross enrolment ratio (%) in Pre-primary schools in East Asia (developing only) to that in Fragile and conflict affected situations?
Make the answer very short. 6.03. What is the ratio of the Gross enrolment ratio (%) in Primary schools in East Asia (developing only) to that in Fragile and conflict affected situations?
Provide a succinct answer. 1.31. What is the ratio of the Gross enrolment ratio (%) of Secondary schools in East Asia (developing only) to that in Fragile and conflict affected situations?
Provide a succinct answer. 1.96. What is the ratio of the Gross enrolment ratio (%) of Tertiary schools in East Asia (developing only) to that in Fragile and conflict affected situations?
Give a very brief answer. 2.31. What is the ratio of the Gross enrolment ratio (%) of Pre-primary schools in Euro area to that in Europe(all income levels)?
Your answer should be very brief. 1.4. What is the ratio of the Gross enrolment ratio (%) of Primary schools in Euro area to that in Europe(all income levels)?
Give a very brief answer. 1.03. What is the ratio of the Gross enrolment ratio (%) in Secondary schools in Euro area to that in Europe(all income levels)?
Your answer should be compact. 1.1. What is the ratio of the Gross enrolment ratio (%) in Tertiary schools in Euro area to that in Europe(all income levels)?
Make the answer very short. 1.03. What is the ratio of the Gross enrolment ratio (%) of Pre-primary schools in Euro area to that in Europe(developing only)?
Your answer should be very brief. 2.59. What is the ratio of the Gross enrolment ratio (%) of Primary schools in Euro area to that in Europe(developing only)?
Provide a succinct answer. 1.06. What is the ratio of the Gross enrolment ratio (%) in Secondary schools in Euro area to that in Europe(developing only)?
Your response must be concise. 1.16. What is the ratio of the Gross enrolment ratio (%) in Tertiary schools in Euro area to that in Europe(developing only)?
Offer a terse response. 1.45. What is the ratio of the Gross enrolment ratio (%) of Pre-primary schools in Euro area to that in European Union?
Your response must be concise. 1.09. What is the ratio of the Gross enrolment ratio (%) of Primary schools in Euro area to that in European Union?
Provide a short and direct response. 1.01. What is the ratio of the Gross enrolment ratio (%) of Secondary schools in Euro area to that in European Union?
Ensure brevity in your answer.  1.03. What is the ratio of the Gross enrolment ratio (%) in Tertiary schools in Euro area to that in European Union?
Ensure brevity in your answer.  0.97. What is the ratio of the Gross enrolment ratio (%) of Pre-primary schools in Euro area to that in Fragile and conflict affected situations?
Your answer should be compact. 12.08. What is the ratio of the Gross enrolment ratio (%) of Primary schools in Euro area to that in Fragile and conflict affected situations?
Your answer should be very brief. 1.17. What is the ratio of the Gross enrolment ratio (%) of Secondary schools in Euro area to that in Fragile and conflict affected situations?
Your answer should be very brief. 2.82. What is the ratio of the Gross enrolment ratio (%) of Tertiary schools in Euro area to that in Fragile and conflict affected situations?
Provide a short and direct response. 7.06. What is the ratio of the Gross enrolment ratio (%) of Pre-primary schools in Europe(all income levels) to that in Europe(developing only)?
Give a very brief answer. 1.85. What is the ratio of the Gross enrolment ratio (%) of Primary schools in Europe(all income levels) to that in Europe(developing only)?
Give a very brief answer. 1.02. What is the ratio of the Gross enrolment ratio (%) in Secondary schools in Europe(all income levels) to that in Europe(developing only)?
Your answer should be very brief. 1.05. What is the ratio of the Gross enrolment ratio (%) in Tertiary schools in Europe(all income levels) to that in Europe(developing only)?
Your response must be concise. 1.4. What is the ratio of the Gross enrolment ratio (%) of Pre-primary schools in Europe(all income levels) to that in European Union?
Your answer should be very brief. 0.78. What is the ratio of the Gross enrolment ratio (%) in Primary schools in Europe(all income levels) to that in European Union?
Keep it short and to the point. 0.98. What is the ratio of the Gross enrolment ratio (%) of Secondary schools in Europe(all income levels) to that in European Union?
Ensure brevity in your answer.  0.93. What is the ratio of the Gross enrolment ratio (%) in Tertiary schools in Europe(all income levels) to that in European Union?
Provide a short and direct response. 0.93. What is the ratio of the Gross enrolment ratio (%) in Pre-primary schools in Europe(all income levels) to that in Fragile and conflict affected situations?
Keep it short and to the point. 8.64. What is the ratio of the Gross enrolment ratio (%) in Primary schools in Europe(all income levels) to that in Fragile and conflict affected situations?
Keep it short and to the point. 1.14. What is the ratio of the Gross enrolment ratio (%) of Secondary schools in Europe(all income levels) to that in Fragile and conflict affected situations?
Provide a short and direct response. 2.57. What is the ratio of the Gross enrolment ratio (%) in Tertiary schools in Europe(all income levels) to that in Fragile and conflict affected situations?
Your answer should be very brief. 6.83. What is the ratio of the Gross enrolment ratio (%) of Pre-primary schools in Europe(developing only) to that in European Union?
Provide a succinct answer. 0.42. What is the ratio of the Gross enrolment ratio (%) of Primary schools in Europe(developing only) to that in European Union?
Provide a short and direct response. 0.96. What is the ratio of the Gross enrolment ratio (%) in Secondary schools in Europe(developing only) to that in European Union?
Your answer should be very brief. 0.89. What is the ratio of the Gross enrolment ratio (%) of Tertiary schools in Europe(developing only) to that in European Union?
Make the answer very short. 0.67. What is the ratio of the Gross enrolment ratio (%) in Pre-primary schools in Europe(developing only) to that in Fragile and conflict affected situations?
Your response must be concise. 4.66. What is the ratio of the Gross enrolment ratio (%) of Primary schools in Europe(developing only) to that in Fragile and conflict affected situations?
Provide a succinct answer. 1.11. What is the ratio of the Gross enrolment ratio (%) of Secondary schools in Europe(developing only) to that in Fragile and conflict affected situations?
Give a very brief answer. 2.44. What is the ratio of the Gross enrolment ratio (%) of Tertiary schools in Europe(developing only) to that in Fragile and conflict affected situations?
Provide a short and direct response. 4.88. What is the ratio of the Gross enrolment ratio (%) in Pre-primary schools in European Union to that in Fragile and conflict affected situations?
Ensure brevity in your answer.  11.1. What is the ratio of the Gross enrolment ratio (%) in Primary schools in European Union to that in Fragile and conflict affected situations?
Give a very brief answer. 1.16. What is the ratio of the Gross enrolment ratio (%) in Secondary schools in European Union to that in Fragile and conflict affected situations?
Make the answer very short. 2.75. What is the ratio of the Gross enrolment ratio (%) in Tertiary schools in European Union to that in Fragile and conflict affected situations?
Provide a succinct answer. 7.31. What is the difference between the highest and the second highest Gross enrolment ratio (%) of Pre-primary schools?
Your answer should be compact. 8.12. What is the difference between the highest and the second highest Gross enrolment ratio (%) in Primary schools?
Your answer should be very brief. 12.17. What is the difference between the highest and the second highest Gross enrolment ratio (%) in Secondary schools?
Your answer should be compact. 2.61. What is the difference between the highest and the second highest Gross enrolment ratio (%) of Tertiary schools?
Offer a very short reply. 2.33. What is the difference between the highest and the lowest Gross enrolment ratio (%) of Pre-primary schools?
Offer a terse response. 92.28. What is the difference between the highest and the lowest Gross enrolment ratio (%) of Primary schools?
Your answer should be compact. 27.74. What is the difference between the highest and the lowest Gross enrolment ratio (%) of Secondary schools?
Your answer should be compact. 67.84. What is the difference between the highest and the lowest Gross enrolment ratio (%) of Tertiary schools?
Offer a very short reply. 59.64. 